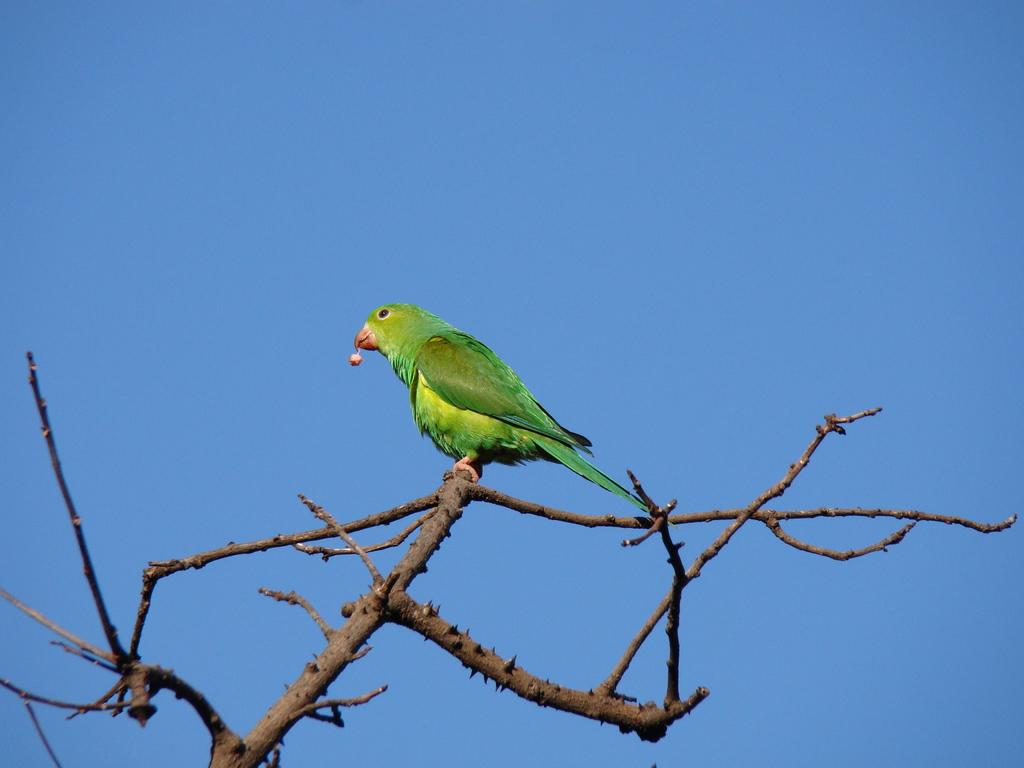What type of animal is in the image? There is a parrot in the image. Where is the parrot located? The parrot is sitting on a branch of a tree. What is the condition of the sky in the image? The sky is clear in the image. What type of joke is the parrot telling in the image? There is no indication in the image that the parrot is telling a joke, as parrots do not have the ability to tell jokes. 